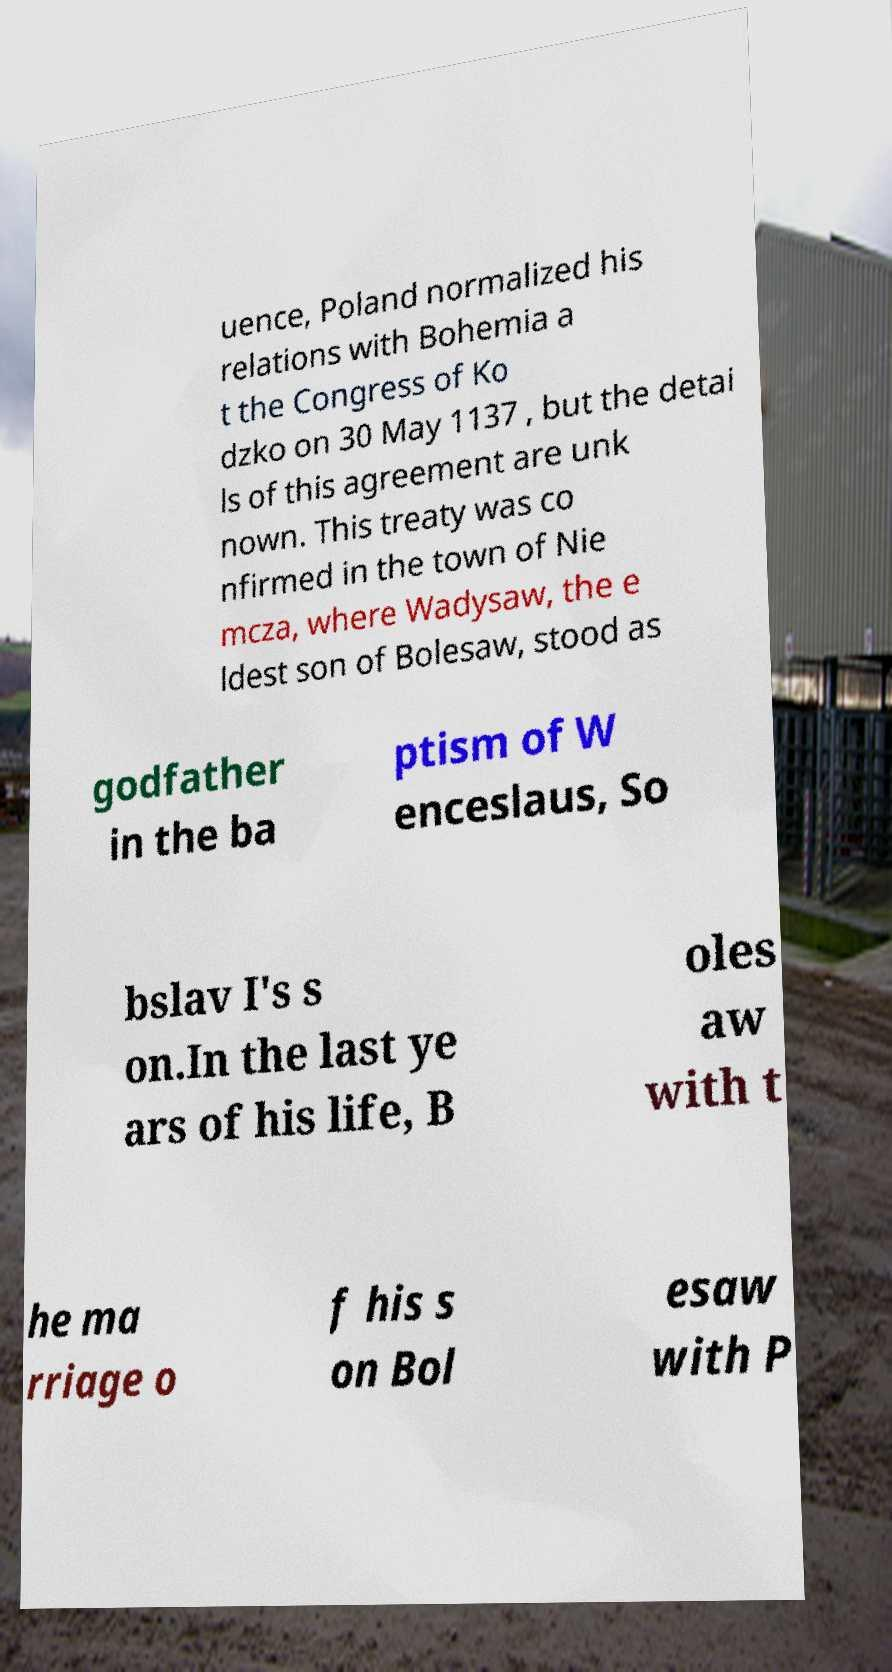Could you extract and type out the text from this image? uence, Poland normalized his relations with Bohemia a t the Congress of Ko dzko on 30 May 1137 , but the detai ls of this agreement are unk nown. This treaty was co nfirmed in the town of Nie mcza, where Wadysaw, the e ldest son of Bolesaw, stood as godfather in the ba ptism of W enceslaus, So bslav I's s on.In the last ye ars of his life, B oles aw with t he ma rriage o f his s on Bol esaw with P 